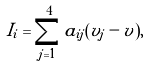Convert formula to latex. <formula><loc_0><loc_0><loc_500><loc_500>I _ { i } = \sum _ { j = 1 } ^ { 4 } a _ { i j } ( v _ { j } - v ) ,</formula> 